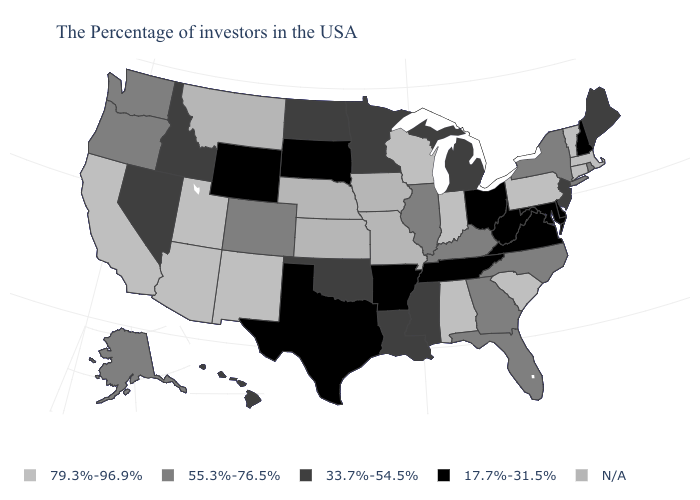What is the value of Arizona?
Answer briefly. 79.3%-96.9%. Which states have the highest value in the USA?
Quick response, please. Massachusetts, Vermont, Connecticut, Pennsylvania, South Carolina, Indiana, Alabama, Wisconsin, New Mexico, Utah, Arizona, California. Name the states that have a value in the range N/A?
Be succinct. Missouri, Iowa, Kansas, Nebraska, Montana. Among the states that border Washington , does Oregon have the lowest value?
Short answer required. No. What is the value of Virginia?
Be succinct. 17.7%-31.5%. Does Nevada have the highest value in the USA?
Concise answer only. No. What is the value of Idaho?
Concise answer only. 33.7%-54.5%. What is the highest value in the South ?
Give a very brief answer. 79.3%-96.9%. Which states have the lowest value in the MidWest?
Keep it brief. Ohio, South Dakota. Among the states that border Colorado , does Oklahoma have the highest value?
Short answer required. No. What is the value of Nebraska?
Concise answer only. N/A. What is the value of Iowa?
Short answer required. N/A. Which states have the lowest value in the West?
Give a very brief answer. Wyoming. Name the states that have a value in the range 17.7%-31.5%?
Give a very brief answer. New Hampshire, Delaware, Maryland, Virginia, West Virginia, Ohio, Tennessee, Arkansas, Texas, South Dakota, Wyoming. 